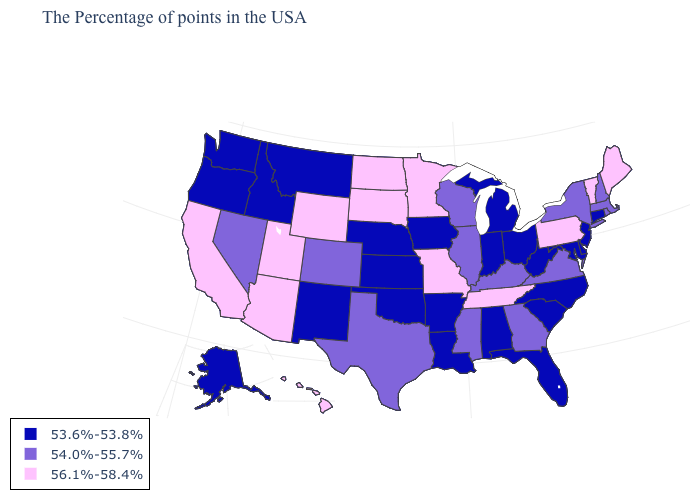What is the value of Mississippi?
Write a very short answer. 54.0%-55.7%. What is the value of Texas?
Answer briefly. 54.0%-55.7%. Name the states that have a value in the range 56.1%-58.4%?
Quick response, please. Maine, Vermont, Pennsylvania, Tennessee, Missouri, Minnesota, South Dakota, North Dakota, Wyoming, Utah, Arizona, California, Hawaii. Name the states that have a value in the range 53.6%-53.8%?
Give a very brief answer. Connecticut, New Jersey, Delaware, Maryland, North Carolina, South Carolina, West Virginia, Ohio, Florida, Michigan, Indiana, Alabama, Louisiana, Arkansas, Iowa, Kansas, Nebraska, Oklahoma, New Mexico, Montana, Idaho, Washington, Oregon, Alaska. Name the states that have a value in the range 56.1%-58.4%?
Short answer required. Maine, Vermont, Pennsylvania, Tennessee, Missouri, Minnesota, South Dakota, North Dakota, Wyoming, Utah, Arizona, California, Hawaii. Name the states that have a value in the range 53.6%-53.8%?
Quick response, please. Connecticut, New Jersey, Delaware, Maryland, North Carolina, South Carolina, West Virginia, Ohio, Florida, Michigan, Indiana, Alabama, Louisiana, Arkansas, Iowa, Kansas, Nebraska, Oklahoma, New Mexico, Montana, Idaho, Washington, Oregon, Alaska. What is the value of Michigan?
Write a very short answer. 53.6%-53.8%. What is the value of Utah?
Quick response, please. 56.1%-58.4%. Does Vermont have the highest value in the Northeast?
Short answer required. Yes. Does Connecticut have the lowest value in the Northeast?
Write a very short answer. Yes. Which states have the lowest value in the South?
Be succinct. Delaware, Maryland, North Carolina, South Carolina, West Virginia, Florida, Alabama, Louisiana, Arkansas, Oklahoma. Name the states that have a value in the range 53.6%-53.8%?
Quick response, please. Connecticut, New Jersey, Delaware, Maryland, North Carolina, South Carolina, West Virginia, Ohio, Florida, Michigan, Indiana, Alabama, Louisiana, Arkansas, Iowa, Kansas, Nebraska, Oklahoma, New Mexico, Montana, Idaho, Washington, Oregon, Alaska. Does New York have the same value as Hawaii?
Keep it brief. No. Name the states that have a value in the range 54.0%-55.7%?
Answer briefly. Massachusetts, Rhode Island, New Hampshire, New York, Virginia, Georgia, Kentucky, Wisconsin, Illinois, Mississippi, Texas, Colorado, Nevada. Which states have the lowest value in the USA?
Keep it brief. Connecticut, New Jersey, Delaware, Maryland, North Carolina, South Carolina, West Virginia, Ohio, Florida, Michigan, Indiana, Alabama, Louisiana, Arkansas, Iowa, Kansas, Nebraska, Oklahoma, New Mexico, Montana, Idaho, Washington, Oregon, Alaska. 